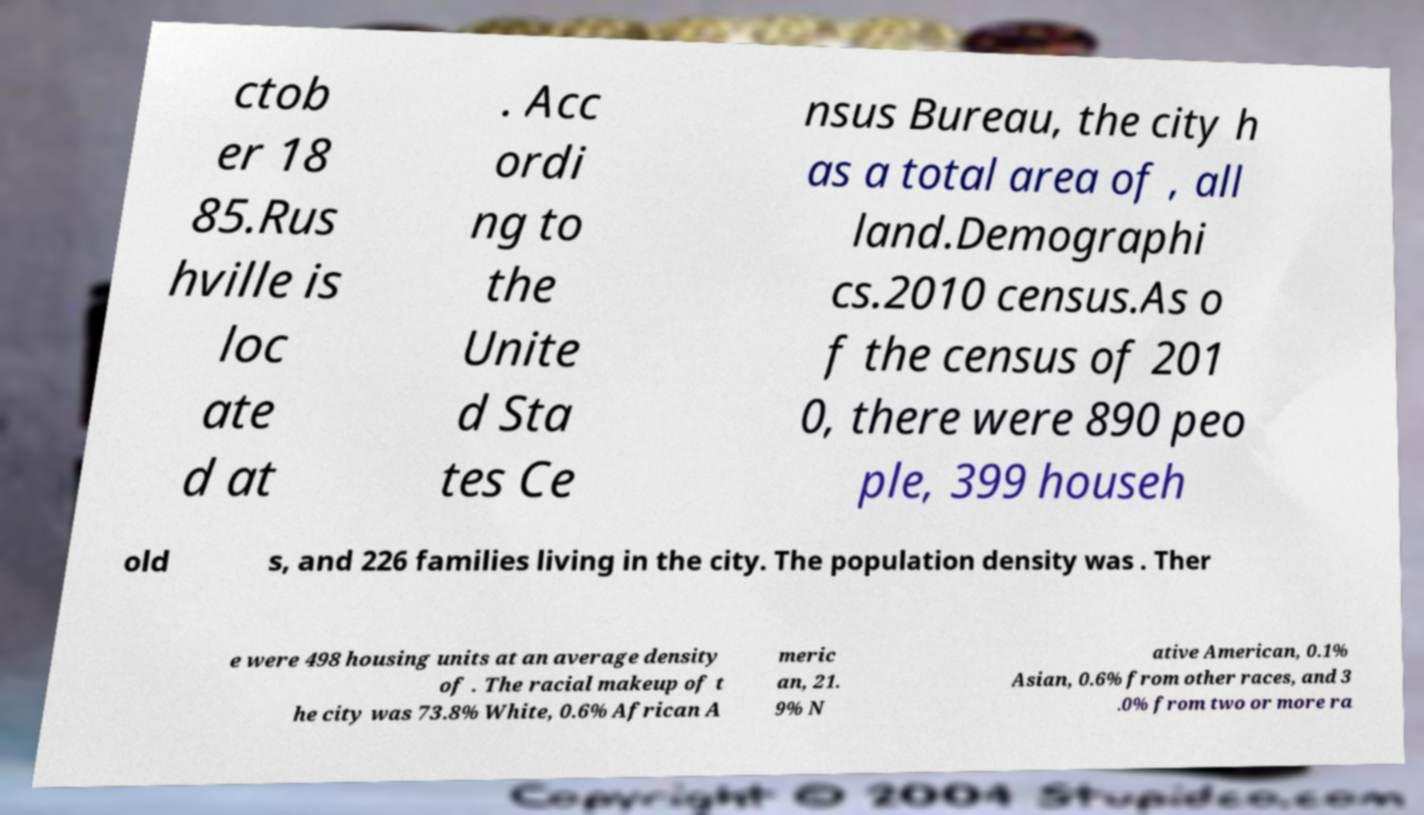Can you read and provide the text displayed in the image?This photo seems to have some interesting text. Can you extract and type it out for me? ctob er 18 85.Rus hville is loc ate d at . Acc ordi ng to the Unite d Sta tes Ce nsus Bureau, the city h as a total area of , all land.Demographi cs.2010 census.As o f the census of 201 0, there were 890 peo ple, 399 househ old s, and 226 families living in the city. The population density was . Ther e were 498 housing units at an average density of . The racial makeup of t he city was 73.8% White, 0.6% African A meric an, 21. 9% N ative American, 0.1% Asian, 0.6% from other races, and 3 .0% from two or more ra 